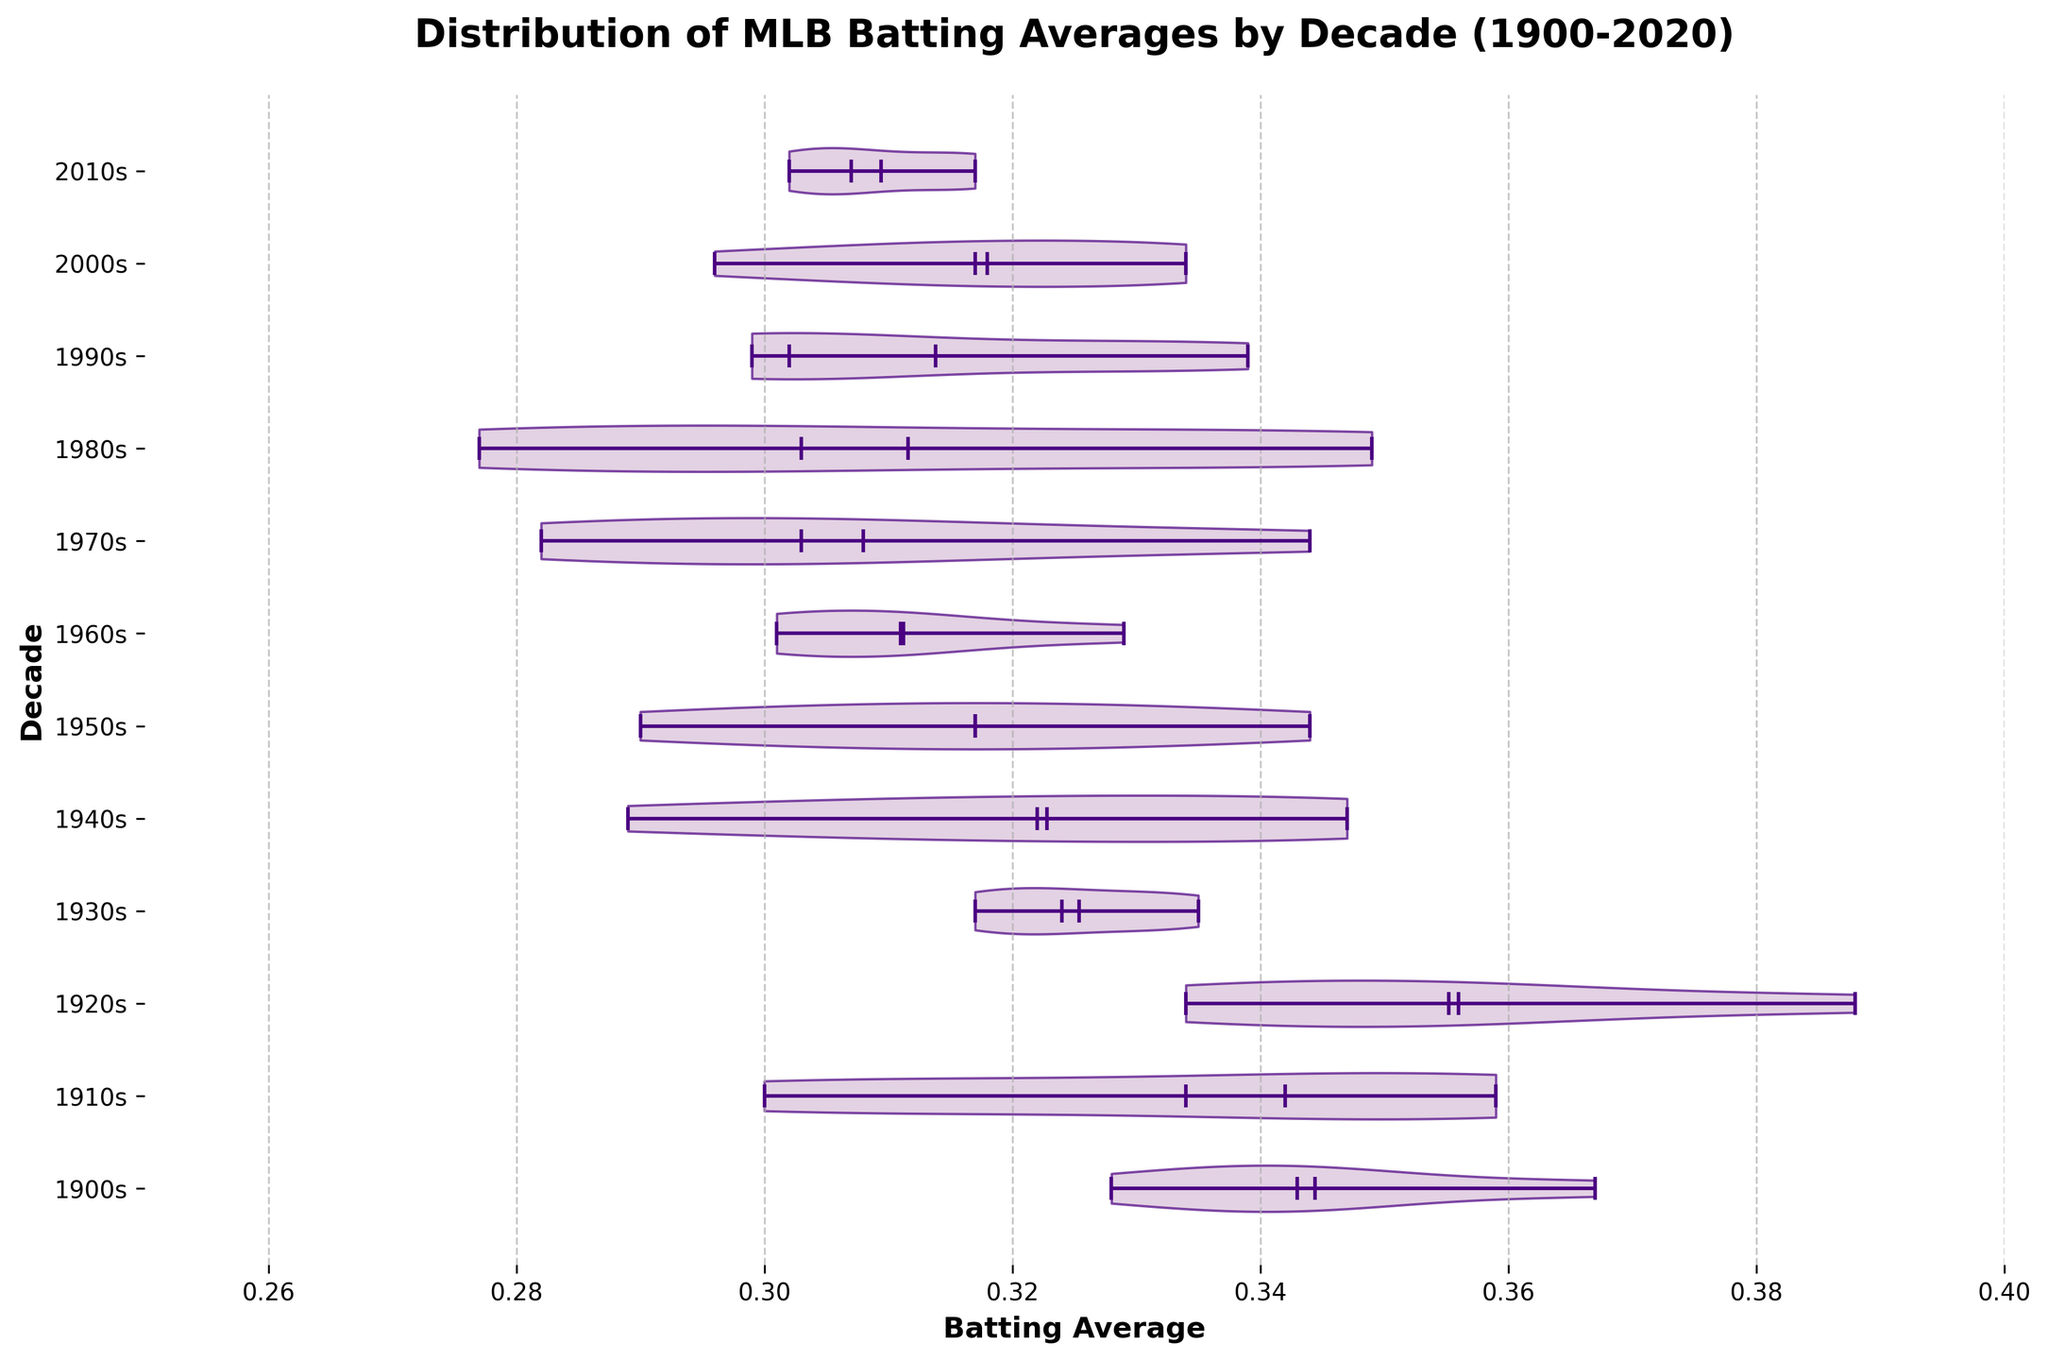What is the title of the figure? The title of the figure is located at the top. It is presented in a larger, bold font.
Answer: Distribution of MLB Batting Averages by Decade (1900-2020) How do the batting averages in the 1910s compare to those in the 2000s? To compare the batting averages between the two decades, observe the width and placement of the violin plots. The batting averages in the 1910s appear to be higher and more spread out towards the upper end compared to the 2000s.
Answer: Higher in the 1910s Which decade has the highest median batting average? The median is indicated by the white dot inside each violin plot. By visually examining all the white dots, the decade with the highest positioned dot is the 1920s.
Answer: 1920s From the figure, what is the minimum batting average across all decades? The minimum batting average is indicated by the bottom edge of the horizontal line inside any violin plot. The lowest point appears slightly below 0.28.
Answer: Below 0.28 Which decade shows the widest distribution of batting averages? The width of the violin plot at its broadest point indicates distribution. The 1910s and 1920s show relatively wide distributions, but the 1910s appear to be the widest overall.
Answer: 1910s What can you infer about the trend in batting averages across the decades? To infer the trend, observe the general position and width of the violin plots across the x-axis from top to bottom. The overall batting averages tend to decrease slightly over the decades, especially noticeable from the early 1900s to the 2000s.
Answer: Decreasing trend Which decade has the narrowest range of batting averages? The range is the difference between the maximum and minimum values within each violin plot. The 1980s plot appears the narrowest, suggesting the smallest range of batting averages.
Answer: 1980s What decade has the most consistent batting averages, as shown by the figure? Consistency can be inferred from the concentration around the mean and the overall shape of the plots. The 2000s show a relatively consistent distribution with less spread compared to earlier decades.
Answer: 2000s What does the color of the violin plots represent in this figure? The color and style of the violin plots are for visual aesthetics and differentiation; it does not encode data but helps in distinguishing between different decades.
Answer: Aesthetic differentiation 